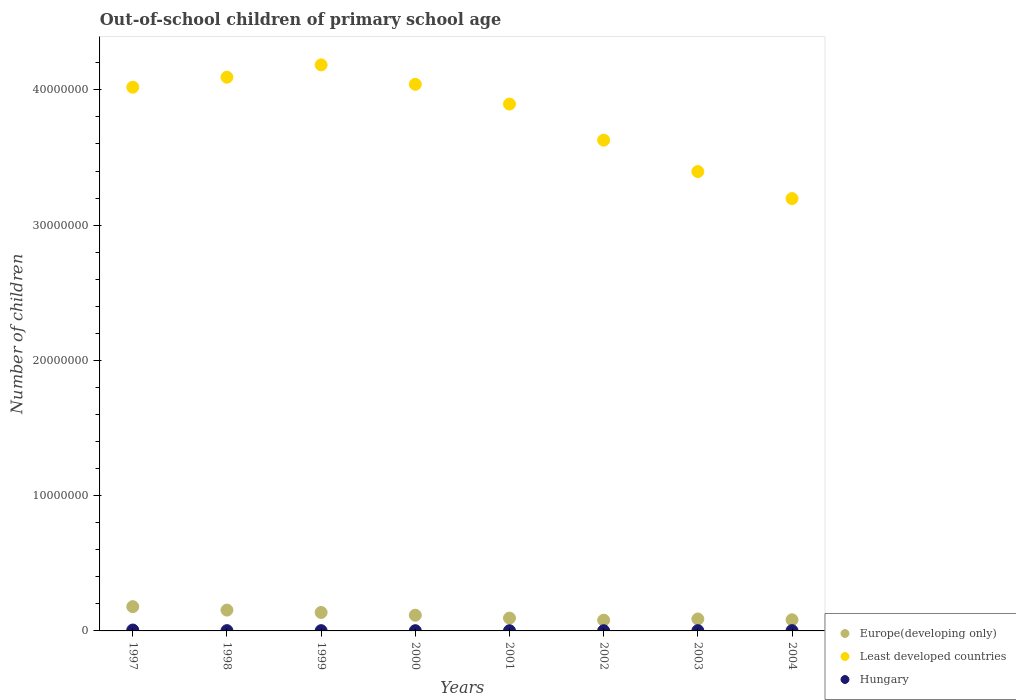Is the number of dotlines equal to the number of legend labels?
Ensure brevity in your answer.  Yes. What is the number of out-of-school children in Least developed countries in 2001?
Offer a very short reply. 3.90e+07. Across all years, what is the maximum number of out-of-school children in Least developed countries?
Ensure brevity in your answer.  4.18e+07. Across all years, what is the minimum number of out-of-school children in Hungary?
Make the answer very short. 1.41e+04. In which year was the number of out-of-school children in Least developed countries maximum?
Provide a succinct answer. 1999. In which year was the number of out-of-school children in Hungary minimum?
Ensure brevity in your answer.  2002. What is the total number of out-of-school children in Least developed countries in the graph?
Give a very brief answer. 3.05e+08. What is the difference between the number of out-of-school children in Hungary in 2003 and that in 2004?
Make the answer very short. -1187. What is the difference between the number of out-of-school children in Hungary in 2004 and the number of out-of-school children in Europe(developing only) in 2003?
Provide a short and direct response. -8.64e+05. What is the average number of out-of-school children in Least developed countries per year?
Make the answer very short. 3.81e+07. In the year 2001, what is the difference between the number of out-of-school children in Hungary and number of out-of-school children in Least developed countries?
Your answer should be compact. -3.89e+07. What is the ratio of the number of out-of-school children in Europe(developing only) in 1999 to that in 2002?
Ensure brevity in your answer.  1.72. Is the number of out-of-school children in Europe(developing only) in 2001 less than that in 2003?
Ensure brevity in your answer.  No. Is the difference between the number of out-of-school children in Hungary in 2002 and 2004 greater than the difference between the number of out-of-school children in Least developed countries in 2002 and 2004?
Your response must be concise. No. What is the difference between the highest and the second highest number of out-of-school children in Hungary?
Make the answer very short. 4.44e+04. What is the difference between the highest and the lowest number of out-of-school children in Europe(developing only)?
Ensure brevity in your answer.  1.00e+06. In how many years, is the number of out-of-school children in Least developed countries greater than the average number of out-of-school children in Least developed countries taken over all years?
Your answer should be very brief. 5. Is the number of out-of-school children in Hungary strictly greater than the number of out-of-school children in Europe(developing only) over the years?
Give a very brief answer. No. Is the number of out-of-school children in Least developed countries strictly less than the number of out-of-school children in Hungary over the years?
Provide a short and direct response. No. What is the difference between two consecutive major ticks on the Y-axis?
Provide a succinct answer. 1.00e+07. How many legend labels are there?
Ensure brevity in your answer.  3. How are the legend labels stacked?
Keep it short and to the point. Vertical. What is the title of the graph?
Your response must be concise. Out-of-school children of primary school age. What is the label or title of the Y-axis?
Provide a succinct answer. Number of children. What is the Number of children in Europe(developing only) in 1997?
Provide a short and direct response. 1.79e+06. What is the Number of children of Least developed countries in 1997?
Keep it short and to the point. 4.02e+07. What is the Number of children of Hungary in 1997?
Ensure brevity in your answer.  6.48e+04. What is the Number of children of Europe(developing only) in 1998?
Offer a terse response. 1.54e+06. What is the Number of children of Least developed countries in 1998?
Provide a short and direct response. 4.09e+07. What is the Number of children in Hungary in 1998?
Your answer should be very brief. 2.01e+04. What is the Number of children of Europe(developing only) in 1999?
Provide a short and direct response. 1.37e+06. What is the Number of children in Least developed countries in 1999?
Provide a short and direct response. 4.18e+07. What is the Number of children in Hungary in 1999?
Your answer should be very brief. 1.93e+04. What is the Number of children in Europe(developing only) in 2000?
Provide a short and direct response. 1.16e+06. What is the Number of children of Least developed countries in 2000?
Provide a succinct answer. 4.04e+07. What is the Number of children in Hungary in 2000?
Your answer should be compact. 1.68e+04. What is the Number of children in Europe(developing only) in 2001?
Offer a very short reply. 9.49e+05. What is the Number of children in Least developed countries in 2001?
Provide a succinct answer. 3.90e+07. What is the Number of children in Hungary in 2001?
Your answer should be very brief. 1.47e+04. What is the Number of children in Europe(developing only) in 2002?
Provide a short and direct response. 7.92e+05. What is the Number of children in Least developed countries in 2002?
Provide a short and direct response. 3.63e+07. What is the Number of children in Hungary in 2002?
Give a very brief answer. 1.41e+04. What is the Number of children of Europe(developing only) in 2003?
Ensure brevity in your answer.  8.84e+05. What is the Number of children of Least developed countries in 2003?
Make the answer very short. 3.40e+07. What is the Number of children of Hungary in 2003?
Make the answer very short. 1.92e+04. What is the Number of children in Europe(developing only) in 2004?
Your response must be concise. 8.25e+05. What is the Number of children of Least developed countries in 2004?
Your answer should be very brief. 3.20e+07. What is the Number of children of Hungary in 2004?
Your answer should be very brief. 2.04e+04. Across all years, what is the maximum Number of children in Europe(developing only)?
Your answer should be compact. 1.79e+06. Across all years, what is the maximum Number of children of Least developed countries?
Your answer should be very brief. 4.18e+07. Across all years, what is the maximum Number of children in Hungary?
Provide a succinct answer. 6.48e+04. Across all years, what is the minimum Number of children of Europe(developing only)?
Your answer should be compact. 7.92e+05. Across all years, what is the minimum Number of children of Least developed countries?
Your answer should be compact. 3.20e+07. Across all years, what is the minimum Number of children in Hungary?
Your response must be concise. 1.41e+04. What is the total Number of children in Europe(developing only) in the graph?
Keep it short and to the point. 9.31e+06. What is the total Number of children in Least developed countries in the graph?
Provide a short and direct response. 3.05e+08. What is the total Number of children in Hungary in the graph?
Your answer should be compact. 1.89e+05. What is the difference between the Number of children of Europe(developing only) in 1997 and that in 1998?
Ensure brevity in your answer.  2.54e+05. What is the difference between the Number of children in Least developed countries in 1997 and that in 1998?
Offer a very short reply. -7.38e+05. What is the difference between the Number of children of Hungary in 1997 and that in 1998?
Provide a short and direct response. 4.47e+04. What is the difference between the Number of children in Europe(developing only) in 1997 and that in 1999?
Make the answer very short. 4.29e+05. What is the difference between the Number of children in Least developed countries in 1997 and that in 1999?
Give a very brief answer. -1.65e+06. What is the difference between the Number of children of Hungary in 1997 and that in 1999?
Make the answer very short. 4.55e+04. What is the difference between the Number of children in Europe(developing only) in 1997 and that in 2000?
Make the answer very short. 6.33e+05. What is the difference between the Number of children in Least developed countries in 1997 and that in 2000?
Your response must be concise. -2.14e+05. What is the difference between the Number of children of Hungary in 1997 and that in 2000?
Your answer should be very brief. 4.80e+04. What is the difference between the Number of children of Europe(developing only) in 1997 and that in 2001?
Make the answer very short. 8.45e+05. What is the difference between the Number of children in Least developed countries in 1997 and that in 2001?
Offer a very short reply. 1.25e+06. What is the difference between the Number of children of Hungary in 1997 and that in 2001?
Keep it short and to the point. 5.01e+04. What is the difference between the Number of children in Europe(developing only) in 1997 and that in 2002?
Give a very brief answer. 1.00e+06. What is the difference between the Number of children in Least developed countries in 1997 and that in 2002?
Offer a terse response. 3.91e+06. What is the difference between the Number of children of Hungary in 1997 and that in 2002?
Your answer should be compact. 5.07e+04. What is the difference between the Number of children in Europe(developing only) in 1997 and that in 2003?
Offer a terse response. 9.11e+05. What is the difference between the Number of children of Least developed countries in 1997 and that in 2003?
Keep it short and to the point. 6.24e+06. What is the difference between the Number of children in Hungary in 1997 and that in 2003?
Provide a succinct answer. 4.56e+04. What is the difference between the Number of children of Europe(developing only) in 1997 and that in 2004?
Offer a very short reply. 9.70e+05. What is the difference between the Number of children in Least developed countries in 1997 and that in 2004?
Give a very brief answer. 8.24e+06. What is the difference between the Number of children in Hungary in 1997 and that in 2004?
Your response must be concise. 4.44e+04. What is the difference between the Number of children of Europe(developing only) in 1998 and that in 1999?
Ensure brevity in your answer.  1.76e+05. What is the difference between the Number of children of Least developed countries in 1998 and that in 1999?
Your answer should be compact. -9.13e+05. What is the difference between the Number of children of Hungary in 1998 and that in 1999?
Offer a very short reply. 743. What is the difference between the Number of children in Europe(developing only) in 1998 and that in 2000?
Keep it short and to the point. 3.79e+05. What is the difference between the Number of children in Least developed countries in 1998 and that in 2000?
Offer a very short reply. 5.24e+05. What is the difference between the Number of children of Hungary in 1998 and that in 2000?
Offer a terse response. 3271. What is the difference between the Number of children in Europe(developing only) in 1998 and that in 2001?
Keep it short and to the point. 5.91e+05. What is the difference between the Number of children of Least developed countries in 1998 and that in 2001?
Give a very brief answer. 1.98e+06. What is the difference between the Number of children in Hungary in 1998 and that in 2001?
Your response must be concise. 5374. What is the difference between the Number of children in Europe(developing only) in 1998 and that in 2002?
Keep it short and to the point. 7.49e+05. What is the difference between the Number of children of Least developed countries in 1998 and that in 2002?
Offer a terse response. 4.65e+06. What is the difference between the Number of children in Hungary in 1998 and that in 2002?
Your answer should be very brief. 5998. What is the difference between the Number of children in Europe(developing only) in 1998 and that in 2003?
Your response must be concise. 6.57e+05. What is the difference between the Number of children in Least developed countries in 1998 and that in 2003?
Make the answer very short. 6.98e+06. What is the difference between the Number of children of Hungary in 1998 and that in 2003?
Make the answer very short. 905. What is the difference between the Number of children in Europe(developing only) in 1998 and that in 2004?
Keep it short and to the point. 7.16e+05. What is the difference between the Number of children in Least developed countries in 1998 and that in 2004?
Offer a very short reply. 8.97e+06. What is the difference between the Number of children in Hungary in 1998 and that in 2004?
Provide a succinct answer. -282. What is the difference between the Number of children in Europe(developing only) in 1999 and that in 2000?
Provide a short and direct response. 2.04e+05. What is the difference between the Number of children of Least developed countries in 1999 and that in 2000?
Give a very brief answer. 1.44e+06. What is the difference between the Number of children in Hungary in 1999 and that in 2000?
Provide a short and direct response. 2528. What is the difference between the Number of children of Europe(developing only) in 1999 and that in 2001?
Make the answer very short. 4.16e+05. What is the difference between the Number of children of Least developed countries in 1999 and that in 2001?
Offer a terse response. 2.90e+06. What is the difference between the Number of children in Hungary in 1999 and that in 2001?
Provide a short and direct response. 4631. What is the difference between the Number of children in Europe(developing only) in 1999 and that in 2002?
Your response must be concise. 5.73e+05. What is the difference between the Number of children of Least developed countries in 1999 and that in 2002?
Give a very brief answer. 5.57e+06. What is the difference between the Number of children of Hungary in 1999 and that in 2002?
Offer a very short reply. 5255. What is the difference between the Number of children of Europe(developing only) in 1999 and that in 2003?
Give a very brief answer. 4.81e+05. What is the difference between the Number of children of Least developed countries in 1999 and that in 2003?
Your response must be concise. 7.89e+06. What is the difference between the Number of children in Hungary in 1999 and that in 2003?
Offer a terse response. 162. What is the difference between the Number of children of Europe(developing only) in 1999 and that in 2004?
Your response must be concise. 5.40e+05. What is the difference between the Number of children in Least developed countries in 1999 and that in 2004?
Your answer should be compact. 9.89e+06. What is the difference between the Number of children in Hungary in 1999 and that in 2004?
Offer a very short reply. -1025. What is the difference between the Number of children of Europe(developing only) in 2000 and that in 2001?
Offer a terse response. 2.12e+05. What is the difference between the Number of children of Least developed countries in 2000 and that in 2001?
Offer a very short reply. 1.46e+06. What is the difference between the Number of children of Hungary in 2000 and that in 2001?
Your answer should be compact. 2103. What is the difference between the Number of children of Europe(developing only) in 2000 and that in 2002?
Keep it short and to the point. 3.70e+05. What is the difference between the Number of children of Least developed countries in 2000 and that in 2002?
Provide a succinct answer. 4.13e+06. What is the difference between the Number of children in Hungary in 2000 and that in 2002?
Keep it short and to the point. 2727. What is the difference between the Number of children in Europe(developing only) in 2000 and that in 2003?
Offer a very short reply. 2.78e+05. What is the difference between the Number of children in Least developed countries in 2000 and that in 2003?
Provide a succinct answer. 6.45e+06. What is the difference between the Number of children of Hungary in 2000 and that in 2003?
Make the answer very short. -2366. What is the difference between the Number of children of Europe(developing only) in 2000 and that in 2004?
Offer a terse response. 3.37e+05. What is the difference between the Number of children in Least developed countries in 2000 and that in 2004?
Provide a short and direct response. 8.45e+06. What is the difference between the Number of children in Hungary in 2000 and that in 2004?
Your answer should be compact. -3553. What is the difference between the Number of children in Europe(developing only) in 2001 and that in 2002?
Provide a short and direct response. 1.58e+05. What is the difference between the Number of children in Least developed countries in 2001 and that in 2002?
Provide a succinct answer. 2.67e+06. What is the difference between the Number of children of Hungary in 2001 and that in 2002?
Keep it short and to the point. 624. What is the difference between the Number of children of Europe(developing only) in 2001 and that in 2003?
Your response must be concise. 6.54e+04. What is the difference between the Number of children in Least developed countries in 2001 and that in 2003?
Provide a short and direct response. 4.99e+06. What is the difference between the Number of children of Hungary in 2001 and that in 2003?
Offer a terse response. -4469. What is the difference between the Number of children of Europe(developing only) in 2001 and that in 2004?
Offer a terse response. 1.25e+05. What is the difference between the Number of children in Least developed countries in 2001 and that in 2004?
Give a very brief answer. 6.99e+06. What is the difference between the Number of children of Hungary in 2001 and that in 2004?
Your response must be concise. -5656. What is the difference between the Number of children in Europe(developing only) in 2002 and that in 2003?
Give a very brief answer. -9.22e+04. What is the difference between the Number of children in Least developed countries in 2002 and that in 2003?
Provide a succinct answer. 2.32e+06. What is the difference between the Number of children of Hungary in 2002 and that in 2003?
Provide a succinct answer. -5093. What is the difference between the Number of children of Europe(developing only) in 2002 and that in 2004?
Provide a short and direct response. -3.28e+04. What is the difference between the Number of children of Least developed countries in 2002 and that in 2004?
Keep it short and to the point. 4.32e+06. What is the difference between the Number of children of Hungary in 2002 and that in 2004?
Ensure brevity in your answer.  -6280. What is the difference between the Number of children in Europe(developing only) in 2003 and that in 2004?
Your answer should be compact. 5.94e+04. What is the difference between the Number of children of Least developed countries in 2003 and that in 2004?
Offer a very short reply. 2.00e+06. What is the difference between the Number of children in Hungary in 2003 and that in 2004?
Provide a short and direct response. -1187. What is the difference between the Number of children in Europe(developing only) in 1997 and the Number of children in Least developed countries in 1998?
Make the answer very short. -3.91e+07. What is the difference between the Number of children in Europe(developing only) in 1997 and the Number of children in Hungary in 1998?
Give a very brief answer. 1.77e+06. What is the difference between the Number of children of Least developed countries in 1997 and the Number of children of Hungary in 1998?
Make the answer very short. 4.02e+07. What is the difference between the Number of children in Europe(developing only) in 1997 and the Number of children in Least developed countries in 1999?
Give a very brief answer. -4.01e+07. What is the difference between the Number of children in Europe(developing only) in 1997 and the Number of children in Hungary in 1999?
Offer a very short reply. 1.78e+06. What is the difference between the Number of children of Least developed countries in 1997 and the Number of children of Hungary in 1999?
Offer a terse response. 4.02e+07. What is the difference between the Number of children of Europe(developing only) in 1997 and the Number of children of Least developed countries in 2000?
Ensure brevity in your answer.  -3.86e+07. What is the difference between the Number of children in Europe(developing only) in 1997 and the Number of children in Hungary in 2000?
Give a very brief answer. 1.78e+06. What is the difference between the Number of children of Least developed countries in 1997 and the Number of children of Hungary in 2000?
Provide a succinct answer. 4.02e+07. What is the difference between the Number of children of Europe(developing only) in 1997 and the Number of children of Least developed countries in 2001?
Offer a terse response. -3.72e+07. What is the difference between the Number of children of Europe(developing only) in 1997 and the Number of children of Hungary in 2001?
Offer a terse response. 1.78e+06. What is the difference between the Number of children in Least developed countries in 1997 and the Number of children in Hungary in 2001?
Make the answer very short. 4.02e+07. What is the difference between the Number of children of Europe(developing only) in 1997 and the Number of children of Least developed countries in 2002?
Ensure brevity in your answer.  -3.45e+07. What is the difference between the Number of children in Europe(developing only) in 1997 and the Number of children in Hungary in 2002?
Make the answer very short. 1.78e+06. What is the difference between the Number of children in Least developed countries in 1997 and the Number of children in Hungary in 2002?
Provide a short and direct response. 4.02e+07. What is the difference between the Number of children in Europe(developing only) in 1997 and the Number of children in Least developed countries in 2003?
Provide a succinct answer. -3.22e+07. What is the difference between the Number of children of Europe(developing only) in 1997 and the Number of children of Hungary in 2003?
Keep it short and to the point. 1.78e+06. What is the difference between the Number of children in Least developed countries in 1997 and the Number of children in Hungary in 2003?
Provide a succinct answer. 4.02e+07. What is the difference between the Number of children in Europe(developing only) in 1997 and the Number of children in Least developed countries in 2004?
Provide a short and direct response. -3.02e+07. What is the difference between the Number of children in Europe(developing only) in 1997 and the Number of children in Hungary in 2004?
Give a very brief answer. 1.77e+06. What is the difference between the Number of children of Least developed countries in 1997 and the Number of children of Hungary in 2004?
Your response must be concise. 4.02e+07. What is the difference between the Number of children in Europe(developing only) in 1998 and the Number of children in Least developed countries in 1999?
Provide a succinct answer. -4.03e+07. What is the difference between the Number of children in Europe(developing only) in 1998 and the Number of children in Hungary in 1999?
Offer a very short reply. 1.52e+06. What is the difference between the Number of children of Least developed countries in 1998 and the Number of children of Hungary in 1999?
Your answer should be very brief. 4.09e+07. What is the difference between the Number of children of Europe(developing only) in 1998 and the Number of children of Least developed countries in 2000?
Offer a terse response. -3.89e+07. What is the difference between the Number of children of Europe(developing only) in 1998 and the Number of children of Hungary in 2000?
Ensure brevity in your answer.  1.52e+06. What is the difference between the Number of children in Least developed countries in 1998 and the Number of children in Hungary in 2000?
Your answer should be compact. 4.09e+07. What is the difference between the Number of children in Europe(developing only) in 1998 and the Number of children in Least developed countries in 2001?
Your answer should be compact. -3.74e+07. What is the difference between the Number of children of Europe(developing only) in 1998 and the Number of children of Hungary in 2001?
Your answer should be compact. 1.53e+06. What is the difference between the Number of children of Least developed countries in 1998 and the Number of children of Hungary in 2001?
Your response must be concise. 4.09e+07. What is the difference between the Number of children of Europe(developing only) in 1998 and the Number of children of Least developed countries in 2002?
Make the answer very short. -3.47e+07. What is the difference between the Number of children of Europe(developing only) in 1998 and the Number of children of Hungary in 2002?
Provide a succinct answer. 1.53e+06. What is the difference between the Number of children in Least developed countries in 1998 and the Number of children in Hungary in 2002?
Give a very brief answer. 4.09e+07. What is the difference between the Number of children of Europe(developing only) in 1998 and the Number of children of Least developed countries in 2003?
Ensure brevity in your answer.  -3.24e+07. What is the difference between the Number of children in Europe(developing only) in 1998 and the Number of children in Hungary in 2003?
Give a very brief answer. 1.52e+06. What is the difference between the Number of children in Least developed countries in 1998 and the Number of children in Hungary in 2003?
Your answer should be very brief. 4.09e+07. What is the difference between the Number of children of Europe(developing only) in 1998 and the Number of children of Least developed countries in 2004?
Your answer should be compact. -3.04e+07. What is the difference between the Number of children in Europe(developing only) in 1998 and the Number of children in Hungary in 2004?
Offer a terse response. 1.52e+06. What is the difference between the Number of children of Least developed countries in 1998 and the Number of children of Hungary in 2004?
Your answer should be compact. 4.09e+07. What is the difference between the Number of children of Europe(developing only) in 1999 and the Number of children of Least developed countries in 2000?
Ensure brevity in your answer.  -3.90e+07. What is the difference between the Number of children in Europe(developing only) in 1999 and the Number of children in Hungary in 2000?
Give a very brief answer. 1.35e+06. What is the difference between the Number of children in Least developed countries in 1999 and the Number of children in Hungary in 2000?
Ensure brevity in your answer.  4.18e+07. What is the difference between the Number of children of Europe(developing only) in 1999 and the Number of children of Least developed countries in 2001?
Give a very brief answer. -3.76e+07. What is the difference between the Number of children of Europe(developing only) in 1999 and the Number of children of Hungary in 2001?
Provide a succinct answer. 1.35e+06. What is the difference between the Number of children in Least developed countries in 1999 and the Number of children in Hungary in 2001?
Your answer should be very brief. 4.18e+07. What is the difference between the Number of children in Europe(developing only) in 1999 and the Number of children in Least developed countries in 2002?
Make the answer very short. -3.49e+07. What is the difference between the Number of children in Europe(developing only) in 1999 and the Number of children in Hungary in 2002?
Your answer should be very brief. 1.35e+06. What is the difference between the Number of children in Least developed countries in 1999 and the Number of children in Hungary in 2002?
Provide a succinct answer. 4.18e+07. What is the difference between the Number of children of Europe(developing only) in 1999 and the Number of children of Least developed countries in 2003?
Ensure brevity in your answer.  -3.26e+07. What is the difference between the Number of children in Europe(developing only) in 1999 and the Number of children in Hungary in 2003?
Provide a succinct answer. 1.35e+06. What is the difference between the Number of children in Least developed countries in 1999 and the Number of children in Hungary in 2003?
Make the answer very short. 4.18e+07. What is the difference between the Number of children of Europe(developing only) in 1999 and the Number of children of Least developed countries in 2004?
Offer a terse response. -3.06e+07. What is the difference between the Number of children in Europe(developing only) in 1999 and the Number of children in Hungary in 2004?
Your answer should be compact. 1.34e+06. What is the difference between the Number of children in Least developed countries in 1999 and the Number of children in Hungary in 2004?
Provide a short and direct response. 4.18e+07. What is the difference between the Number of children of Europe(developing only) in 2000 and the Number of children of Least developed countries in 2001?
Offer a very short reply. -3.78e+07. What is the difference between the Number of children in Europe(developing only) in 2000 and the Number of children in Hungary in 2001?
Your answer should be very brief. 1.15e+06. What is the difference between the Number of children in Least developed countries in 2000 and the Number of children in Hungary in 2001?
Provide a short and direct response. 4.04e+07. What is the difference between the Number of children of Europe(developing only) in 2000 and the Number of children of Least developed countries in 2002?
Your response must be concise. -3.51e+07. What is the difference between the Number of children in Europe(developing only) in 2000 and the Number of children in Hungary in 2002?
Make the answer very short. 1.15e+06. What is the difference between the Number of children in Least developed countries in 2000 and the Number of children in Hungary in 2002?
Your answer should be very brief. 4.04e+07. What is the difference between the Number of children of Europe(developing only) in 2000 and the Number of children of Least developed countries in 2003?
Keep it short and to the point. -3.28e+07. What is the difference between the Number of children of Europe(developing only) in 2000 and the Number of children of Hungary in 2003?
Give a very brief answer. 1.14e+06. What is the difference between the Number of children of Least developed countries in 2000 and the Number of children of Hungary in 2003?
Offer a terse response. 4.04e+07. What is the difference between the Number of children in Europe(developing only) in 2000 and the Number of children in Least developed countries in 2004?
Keep it short and to the point. -3.08e+07. What is the difference between the Number of children of Europe(developing only) in 2000 and the Number of children of Hungary in 2004?
Give a very brief answer. 1.14e+06. What is the difference between the Number of children in Least developed countries in 2000 and the Number of children in Hungary in 2004?
Keep it short and to the point. 4.04e+07. What is the difference between the Number of children of Europe(developing only) in 2001 and the Number of children of Least developed countries in 2002?
Your answer should be very brief. -3.53e+07. What is the difference between the Number of children in Europe(developing only) in 2001 and the Number of children in Hungary in 2002?
Keep it short and to the point. 9.35e+05. What is the difference between the Number of children in Least developed countries in 2001 and the Number of children in Hungary in 2002?
Offer a terse response. 3.89e+07. What is the difference between the Number of children in Europe(developing only) in 2001 and the Number of children in Least developed countries in 2003?
Your response must be concise. -3.30e+07. What is the difference between the Number of children in Europe(developing only) in 2001 and the Number of children in Hungary in 2003?
Keep it short and to the point. 9.30e+05. What is the difference between the Number of children of Least developed countries in 2001 and the Number of children of Hungary in 2003?
Provide a short and direct response. 3.89e+07. What is the difference between the Number of children in Europe(developing only) in 2001 and the Number of children in Least developed countries in 2004?
Your response must be concise. -3.10e+07. What is the difference between the Number of children in Europe(developing only) in 2001 and the Number of children in Hungary in 2004?
Give a very brief answer. 9.29e+05. What is the difference between the Number of children in Least developed countries in 2001 and the Number of children in Hungary in 2004?
Offer a terse response. 3.89e+07. What is the difference between the Number of children of Europe(developing only) in 2002 and the Number of children of Least developed countries in 2003?
Keep it short and to the point. -3.32e+07. What is the difference between the Number of children of Europe(developing only) in 2002 and the Number of children of Hungary in 2003?
Your answer should be very brief. 7.73e+05. What is the difference between the Number of children in Least developed countries in 2002 and the Number of children in Hungary in 2003?
Keep it short and to the point. 3.63e+07. What is the difference between the Number of children of Europe(developing only) in 2002 and the Number of children of Least developed countries in 2004?
Offer a very short reply. -3.12e+07. What is the difference between the Number of children of Europe(developing only) in 2002 and the Number of children of Hungary in 2004?
Offer a very short reply. 7.71e+05. What is the difference between the Number of children in Least developed countries in 2002 and the Number of children in Hungary in 2004?
Offer a terse response. 3.63e+07. What is the difference between the Number of children in Europe(developing only) in 2003 and the Number of children in Least developed countries in 2004?
Offer a very short reply. -3.11e+07. What is the difference between the Number of children of Europe(developing only) in 2003 and the Number of children of Hungary in 2004?
Offer a very short reply. 8.64e+05. What is the difference between the Number of children of Least developed countries in 2003 and the Number of children of Hungary in 2004?
Your response must be concise. 3.39e+07. What is the average Number of children of Europe(developing only) per year?
Your answer should be compact. 1.16e+06. What is the average Number of children in Least developed countries per year?
Keep it short and to the point. 3.81e+07. What is the average Number of children in Hungary per year?
Your answer should be very brief. 2.37e+04. In the year 1997, what is the difference between the Number of children of Europe(developing only) and Number of children of Least developed countries?
Offer a terse response. -3.84e+07. In the year 1997, what is the difference between the Number of children in Europe(developing only) and Number of children in Hungary?
Your answer should be compact. 1.73e+06. In the year 1997, what is the difference between the Number of children in Least developed countries and Number of children in Hungary?
Provide a succinct answer. 4.01e+07. In the year 1998, what is the difference between the Number of children of Europe(developing only) and Number of children of Least developed countries?
Your answer should be very brief. -3.94e+07. In the year 1998, what is the difference between the Number of children in Europe(developing only) and Number of children in Hungary?
Make the answer very short. 1.52e+06. In the year 1998, what is the difference between the Number of children in Least developed countries and Number of children in Hungary?
Make the answer very short. 4.09e+07. In the year 1999, what is the difference between the Number of children of Europe(developing only) and Number of children of Least developed countries?
Make the answer very short. -4.05e+07. In the year 1999, what is the difference between the Number of children of Europe(developing only) and Number of children of Hungary?
Ensure brevity in your answer.  1.35e+06. In the year 1999, what is the difference between the Number of children of Least developed countries and Number of children of Hungary?
Provide a succinct answer. 4.18e+07. In the year 2000, what is the difference between the Number of children of Europe(developing only) and Number of children of Least developed countries?
Give a very brief answer. -3.92e+07. In the year 2000, what is the difference between the Number of children in Europe(developing only) and Number of children in Hungary?
Your response must be concise. 1.14e+06. In the year 2000, what is the difference between the Number of children in Least developed countries and Number of children in Hungary?
Your response must be concise. 4.04e+07. In the year 2001, what is the difference between the Number of children in Europe(developing only) and Number of children in Least developed countries?
Your response must be concise. -3.80e+07. In the year 2001, what is the difference between the Number of children in Europe(developing only) and Number of children in Hungary?
Offer a terse response. 9.35e+05. In the year 2001, what is the difference between the Number of children of Least developed countries and Number of children of Hungary?
Make the answer very short. 3.89e+07. In the year 2002, what is the difference between the Number of children in Europe(developing only) and Number of children in Least developed countries?
Ensure brevity in your answer.  -3.55e+07. In the year 2002, what is the difference between the Number of children of Europe(developing only) and Number of children of Hungary?
Offer a terse response. 7.78e+05. In the year 2002, what is the difference between the Number of children in Least developed countries and Number of children in Hungary?
Offer a very short reply. 3.63e+07. In the year 2003, what is the difference between the Number of children in Europe(developing only) and Number of children in Least developed countries?
Provide a short and direct response. -3.31e+07. In the year 2003, what is the difference between the Number of children of Europe(developing only) and Number of children of Hungary?
Your answer should be very brief. 8.65e+05. In the year 2003, what is the difference between the Number of children in Least developed countries and Number of children in Hungary?
Offer a terse response. 3.39e+07. In the year 2004, what is the difference between the Number of children of Europe(developing only) and Number of children of Least developed countries?
Your answer should be very brief. -3.11e+07. In the year 2004, what is the difference between the Number of children of Europe(developing only) and Number of children of Hungary?
Offer a very short reply. 8.04e+05. In the year 2004, what is the difference between the Number of children in Least developed countries and Number of children in Hungary?
Ensure brevity in your answer.  3.19e+07. What is the ratio of the Number of children of Europe(developing only) in 1997 to that in 1998?
Your response must be concise. 1.16. What is the ratio of the Number of children of Hungary in 1997 to that in 1998?
Give a very brief answer. 3.23. What is the ratio of the Number of children in Europe(developing only) in 1997 to that in 1999?
Make the answer very short. 1.31. What is the ratio of the Number of children of Least developed countries in 1997 to that in 1999?
Ensure brevity in your answer.  0.96. What is the ratio of the Number of children of Hungary in 1997 to that in 1999?
Your answer should be very brief. 3.35. What is the ratio of the Number of children in Europe(developing only) in 1997 to that in 2000?
Give a very brief answer. 1.54. What is the ratio of the Number of children in Least developed countries in 1997 to that in 2000?
Your answer should be compact. 0.99. What is the ratio of the Number of children in Hungary in 1997 to that in 2000?
Ensure brevity in your answer.  3.85. What is the ratio of the Number of children of Europe(developing only) in 1997 to that in 2001?
Your answer should be compact. 1.89. What is the ratio of the Number of children of Least developed countries in 1997 to that in 2001?
Your answer should be compact. 1.03. What is the ratio of the Number of children of Hungary in 1997 to that in 2001?
Provide a short and direct response. 4.4. What is the ratio of the Number of children of Europe(developing only) in 1997 to that in 2002?
Your response must be concise. 2.27. What is the ratio of the Number of children in Least developed countries in 1997 to that in 2002?
Offer a very short reply. 1.11. What is the ratio of the Number of children in Hungary in 1997 to that in 2002?
Your response must be concise. 4.6. What is the ratio of the Number of children in Europe(developing only) in 1997 to that in 2003?
Your answer should be very brief. 2.03. What is the ratio of the Number of children of Least developed countries in 1997 to that in 2003?
Your answer should be compact. 1.18. What is the ratio of the Number of children of Hungary in 1997 to that in 2003?
Your answer should be compact. 3.38. What is the ratio of the Number of children in Europe(developing only) in 1997 to that in 2004?
Make the answer very short. 2.18. What is the ratio of the Number of children in Least developed countries in 1997 to that in 2004?
Ensure brevity in your answer.  1.26. What is the ratio of the Number of children of Hungary in 1997 to that in 2004?
Offer a very short reply. 3.18. What is the ratio of the Number of children of Europe(developing only) in 1998 to that in 1999?
Provide a succinct answer. 1.13. What is the ratio of the Number of children of Least developed countries in 1998 to that in 1999?
Ensure brevity in your answer.  0.98. What is the ratio of the Number of children in Hungary in 1998 to that in 1999?
Your response must be concise. 1.04. What is the ratio of the Number of children of Europe(developing only) in 1998 to that in 2000?
Make the answer very short. 1.33. What is the ratio of the Number of children in Least developed countries in 1998 to that in 2000?
Your answer should be compact. 1.01. What is the ratio of the Number of children in Hungary in 1998 to that in 2000?
Ensure brevity in your answer.  1.19. What is the ratio of the Number of children in Europe(developing only) in 1998 to that in 2001?
Offer a very short reply. 1.62. What is the ratio of the Number of children in Least developed countries in 1998 to that in 2001?
Make the answer very short. 1.05. What is the ratio of the Number of children of Hungary in 1998 to that in 2001?
Provide a short and direct response. 1.37. What is the ratio of the Number of children in Europe(developing only) in 1998 to that in 2002?
Your response must be concise. 1.95. What is the ratio of the Number of children in Least developed countries in 1998 to that in 2002?
Your answer should be compact. 1.13. What is the ratio of the Number of children of Hungary in 1998 to that in 2002?
Your answer should be very brief. 1.43. What is the ratio of the Number of children in Europe(developing only) in 1998 to that in 2003?
Ensure brevity in your answer.  1.74. What is the ratio of the Number of children of Least developed countries in 1998 to that in 2003?
Ensure brevity in your answer.  1.21. What is the ratio of the Number of children in Hungary in 1998 to that in 2003?
Keep it short and to the point. 1.05. What is the ratio of the Number of children of Europe(developing only) in 1998 to that in 2004?
Make the answer very short. 1.87. What is the ratio of the Number of children of Least developed countries in 1998 to that in 2004?
Give a very brief answer. 1.28. What is the ratio of the Number of children of Hungary in 1998 to that in 2004?
Your answer should be very brief. 0.99. What is the ratio of the Number of children in Europe(developing only) in 1999 to that in 2000?
Make the answer very short. 1.18. What is the ratio of the Number of children in Least developed countries in 1999 to that in 2000?
Your response must be concise. 1.04. What is the ratio of the Number of children in Hungary in 1999 to that in 2000?
Offer a very short reply. 1.15. What is the ratio of the Number of children in Europe(developing only) in 1999 to that in 2001?
Your answer should be very brief. 1.44. What is the ratio of the Number of children in Least developed countries in 1999 to that in 2001?
Your answer should be very brief. 1.07. What is the ratio of the Number of children of Hungary in 1999 to that in 2001?
Make the answer very short. 1.31. What is the ratio of the Number of children in Europe(developing only) in 1999 to that in 2002?
Offer a very short reply. 1.72. What is the ratio of the Number of children in Least developed countries in 1999 to that in 2002?
Provide a short and direct response. 1.15. What is the ratio of the Number of children in Hungary in 1999 to that in 2002?
Make the answer very short. 1.37. What is the ratio of the Number of children of Europe(developing only) in 1999 to that in 2003?
Your response must be concise. 1.54. What is the ratio of the Number of children of Least developed countries in 1999 to that in 2003?
Offer a terse response. 1.23. What is the ratio of the Number of children in Hungary in 1999 to that in 2003?
Offer a terse response. 1.01. What is the ratio of the Number of children of Europe(developing only) in 1999 to that in 2004?
Make the answer very short. 1.66. What is the ratio of the Number of children of Least developed countries in 1999 to that in 2004?
Your answer should be very brief. 1.31. What is the ratio of the Number of children of Hungary in 1999 to that in 2004?
Keep it short and to the point. 0.95. What is the ratio of the Number of children of Europe(developing only) in 2000 to that in 2001?
Give a very brief answer. 1.22. What is the ratio of the Number of children in Least developed countries in 2000 to that in 2001?
Offer a very short reply. 1.04. What is the ratio of the Number of children of Hungary in 2000 to that in 2001?
Offer a very short reply. 1.14. What is the ratio of the Number of children of Europe(developing only) in 2000 to that in 2002?
Your response must be concise. 1.47. What is the ratio of the Number of children of Least developed countries in 2000 to that in 2002?
Your response must be concise. 1.11. What is the ratio of the Number of children of Hungary in 2000 to that in 2002?
Your response must be concise. 1.19. What is the ratio of the Number of children of Europe(developing only) in 2000 to that in 2003?
Offer a very short reply. 1.31. What is the ratio of the Number of children in Least developed countries in 2000 to that in 2003?
Your answer should be very brief. 1.19. What is the ratio of the Number of children of Hungary in 2000 to that in 2003?
Your answer should be compact. 0.88. What is the ratio of the Number of children of Europe(developing only) in 2000 to that in 2004?
Your answer should be compact. 1.41. What is the ratio of the Number of children of Least developed countries in 2000 to that in 2004?
Provide a succinct answer. 1.26. What is the ratio of the Number of children in Hungary in 2000 to that in 2004?
Offer a terse response. 0.83. What is the ratio of the Number of children of Europe(developing only) in 2001 to that in 2002?
Provide a short and direct response. 1.2. What is the ratio of the Number of children in Least developed countries in 2001 to that in 2002?
Provide a short and direct response. 1.07. What is the ratio of the Number of children of Hungary in 2001 to that in 2002?
Your response must be concise. 1.04. What is the ratio of the Number of children of Europe(developing only) in 2001 to that in 2003?
Provide a short and direct response. 1.07. What is the ratio of the Number of children in Least developed countries in 2001 to that in 2003?
Your answer should be very brief. 1.15. What is the ratio of the Number of children in Hungary in 2001 to that in 2003?
Offer a very short reply. 0.77. What is the ratio of the Number of children in Europe(developing only) in 2001 to that in 2004?
Provide a short and direct response. 1.15. What is the ratio of the Number of children in Least developed countries in 2001 to that in 2004?
Make the answer very short. 1.22. What is the ratio of the Number of children in Hungary in 2001 to that in 2004?
Give a very brief answer. 0.72. What is the ratio of the Number of children of Europe(developing only) in 2002 to that in 2003?
Your answer should be very brief. 0.9. What is the ratio of the Number of children of Least developed countries in 2002 to that in 2003?
Your answer should be very brief. 1.07. What is the ratio of the Number of children in Hungary in 2002 to that in 2003?
Keep it short and to the point. 0.73. What is the ratio of the Number of children in Europe(developing only) in 2002 to that in 2004?
Offer a very short reply. 0.96. What is the ratio of the Number of children in Least developed countries in 2002 to that in 2004?
Your answer should be very brief. 1.14. What is the ratio of the Number of children in Hungary in 2002 to that in 2004?
Keep it short and to the point. 0.69. What is the ratio of the Number of children of Europe(developing only) in 2003 to that in 2004?
Offer a very short reply. 1.07. What is the ratio of the Number of children of Hungary in 2003 to that in 2004?
Your response must be concise. 0.94. What is the difference between the highest and the second highest Number of children in Europe(developing only)?
Offer a very short reply. 2.54e+05. What is the difference between the highest and the second highest Number of children of Least developed countries?
Provide a succinct answer. 9.13e+05. What is the difference between the highest and the second highest Number of children of Hungary?
Offer a very short reply. 4.44e+04. What is the difference between the highest and the lowest Number of children in Europe(developing only)?
Your answer should be very brief. 1.00e+06. What is the difference between the highest and the lowest Number of children of Least developed countries?
Provide a short and direct response. 9.89e+06. What is the difference between the highest and the lowest Number of children in Hungary?
Your answer should be compact. 5.07e+04. 